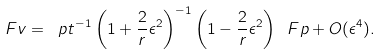Convert formula to latex. <formula><loc_0><loc_0><loc_500><loc_500>\ F v = \ p t ^ { - 1 } \left ( 1 + \frac { 2 } { r } \epsilon ^ { 2 } \right ) ^ { - 1 } \left ( 1 - \frac { 2 } { r } \epsilon ^ { 2 } \right ) \ F p + O ( \epsilon ^ { 4 } ) .</formula> 